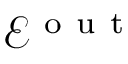Convert formula to latex. <formula><loc_0><loc_0><loc_500><loc_500>\mathcal { E } ^ { o u t }</formula> 